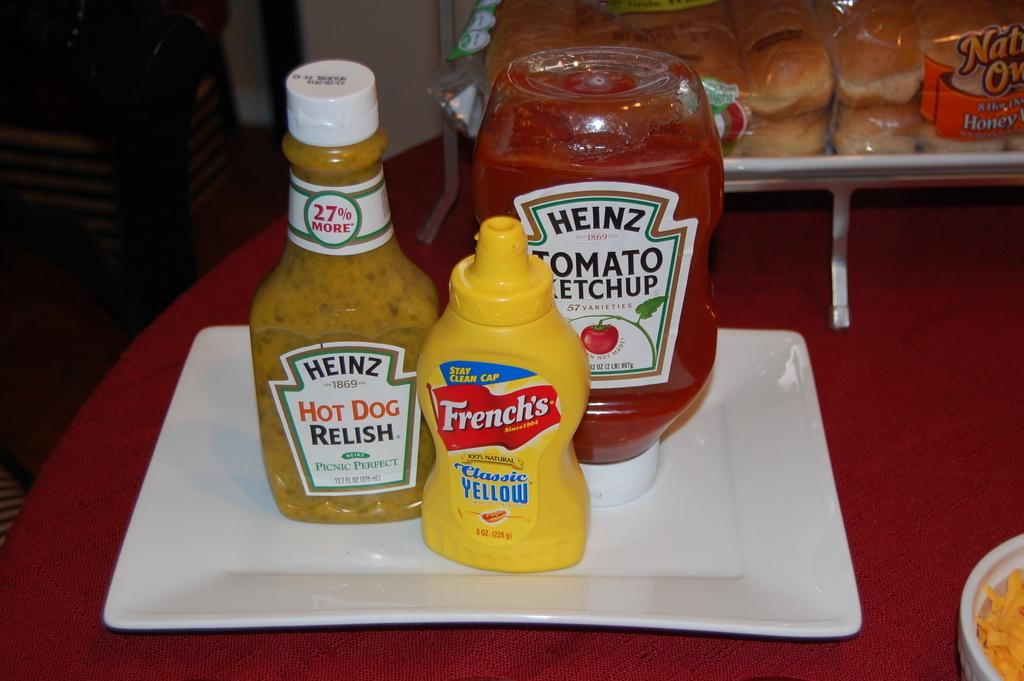What is brand of ketchup?
Provide a succinct answer. Heinz. 